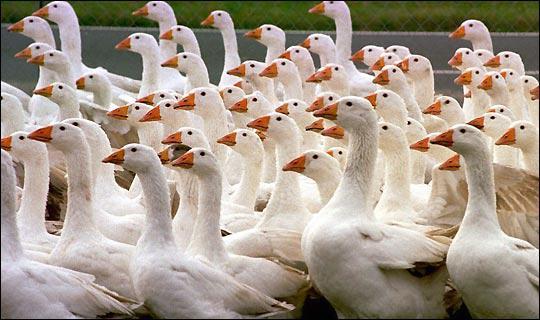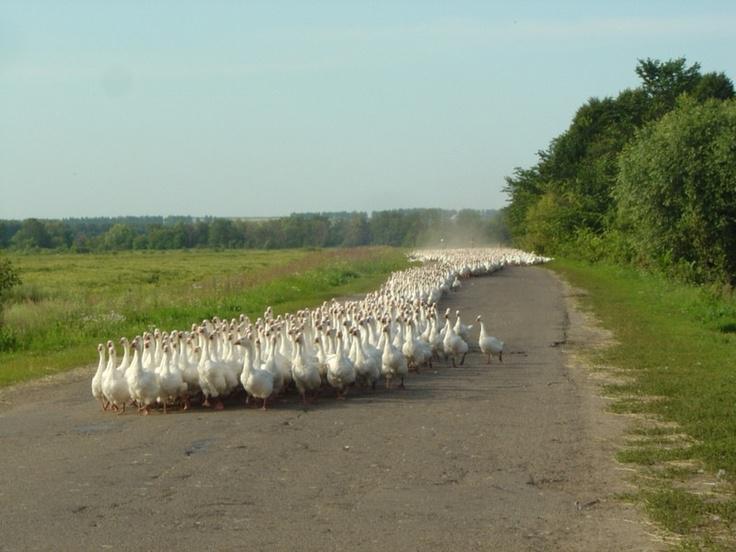The first image is the image on the left, the second image is the image on the right. Examine the images to the left and right. Is the description "One image features multiple ducks on a country road, and the other image shows a mass of white ducks that are not in flight." accurate? Answer yes or no. Yes. The first image is the image on the left, the second image is the image on the right. For the images displayed, is the sentence "Geese are waddling on a road in both images." factually correct? Answer yes or no. Yes. 